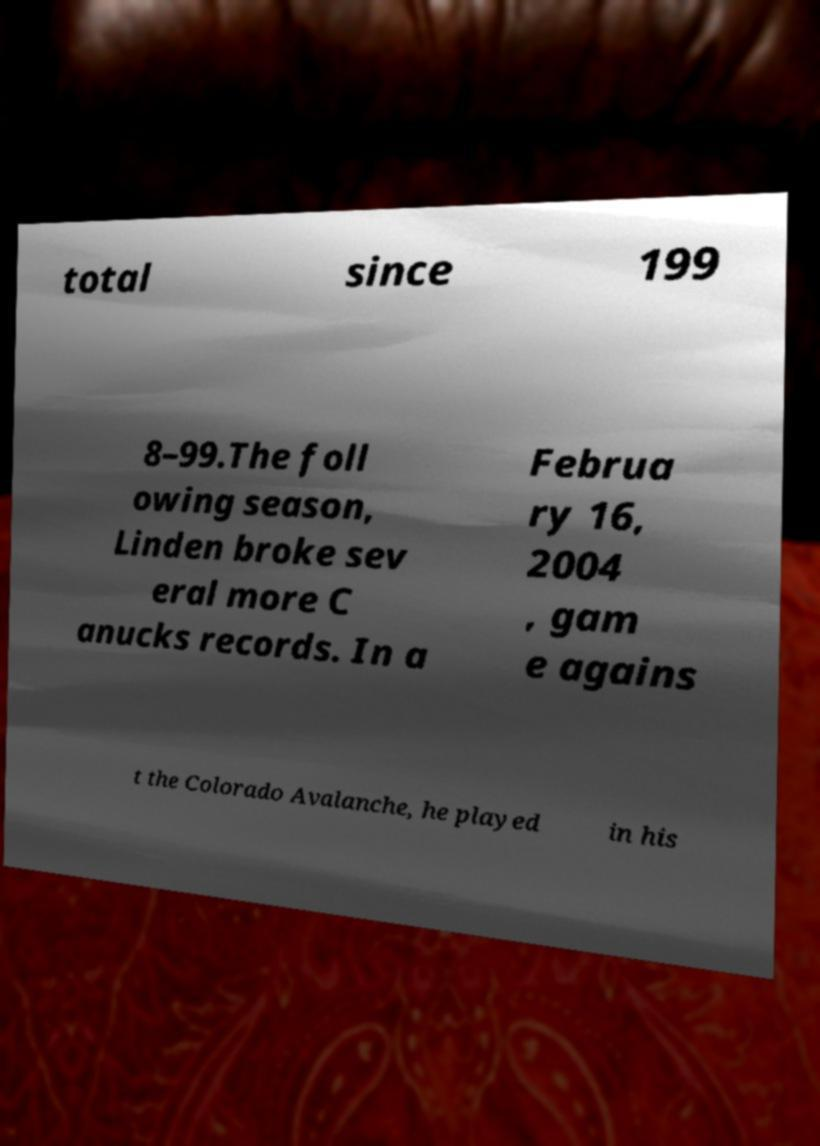Can you read and provide the text displayed in the image?This photo seems to have some interesting text. Can you extract and type it out for me? total since 199 8–99.The foll owing season, Linden broke sev eral more C anucks records. In a Februa ry 16, 2004 , gam e agains t the Colorado Avalanche, he played in his 